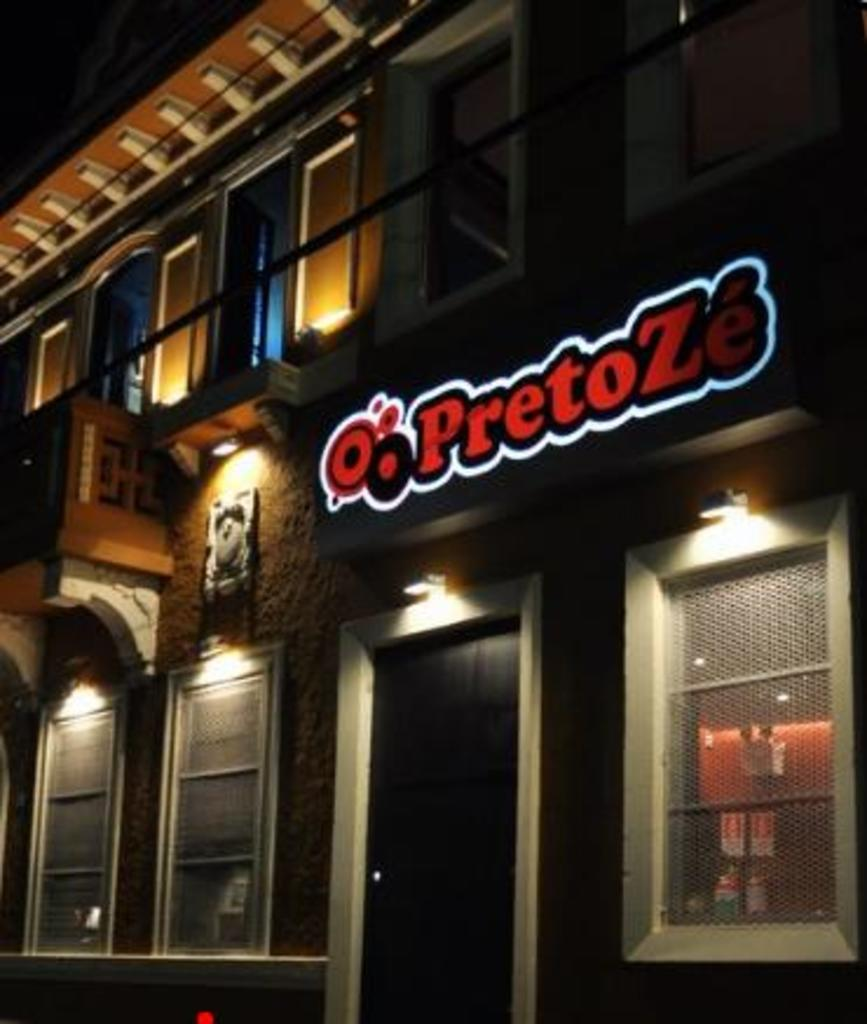What type of structure is visible in the image? There is a building in the image. What architectural features can be seen on the building? There are windows and meshes visible on the building. What type of illumination is present in the image? There are lights in the image. What is attached to the wall in the image? There is a board on the wall in the image. Reasoning: Let's let's think step by step in order to produce the conversation. We start by identifying the main subject of the image, which is the building. Then, we describe specific features of the building, such as the windows, meshes, and lights. Finally, we mention the presence of a board attached to the wall. Absurd Question/Answer: What color is the owner's spot in the image? There is no mention of an owner or a spot in the image. What is the current temperature of the spot owned by the person in the image? There is no mention of a person, an owner, or a spot in the image, so it is not possible to determine the current temperature of any spot. 